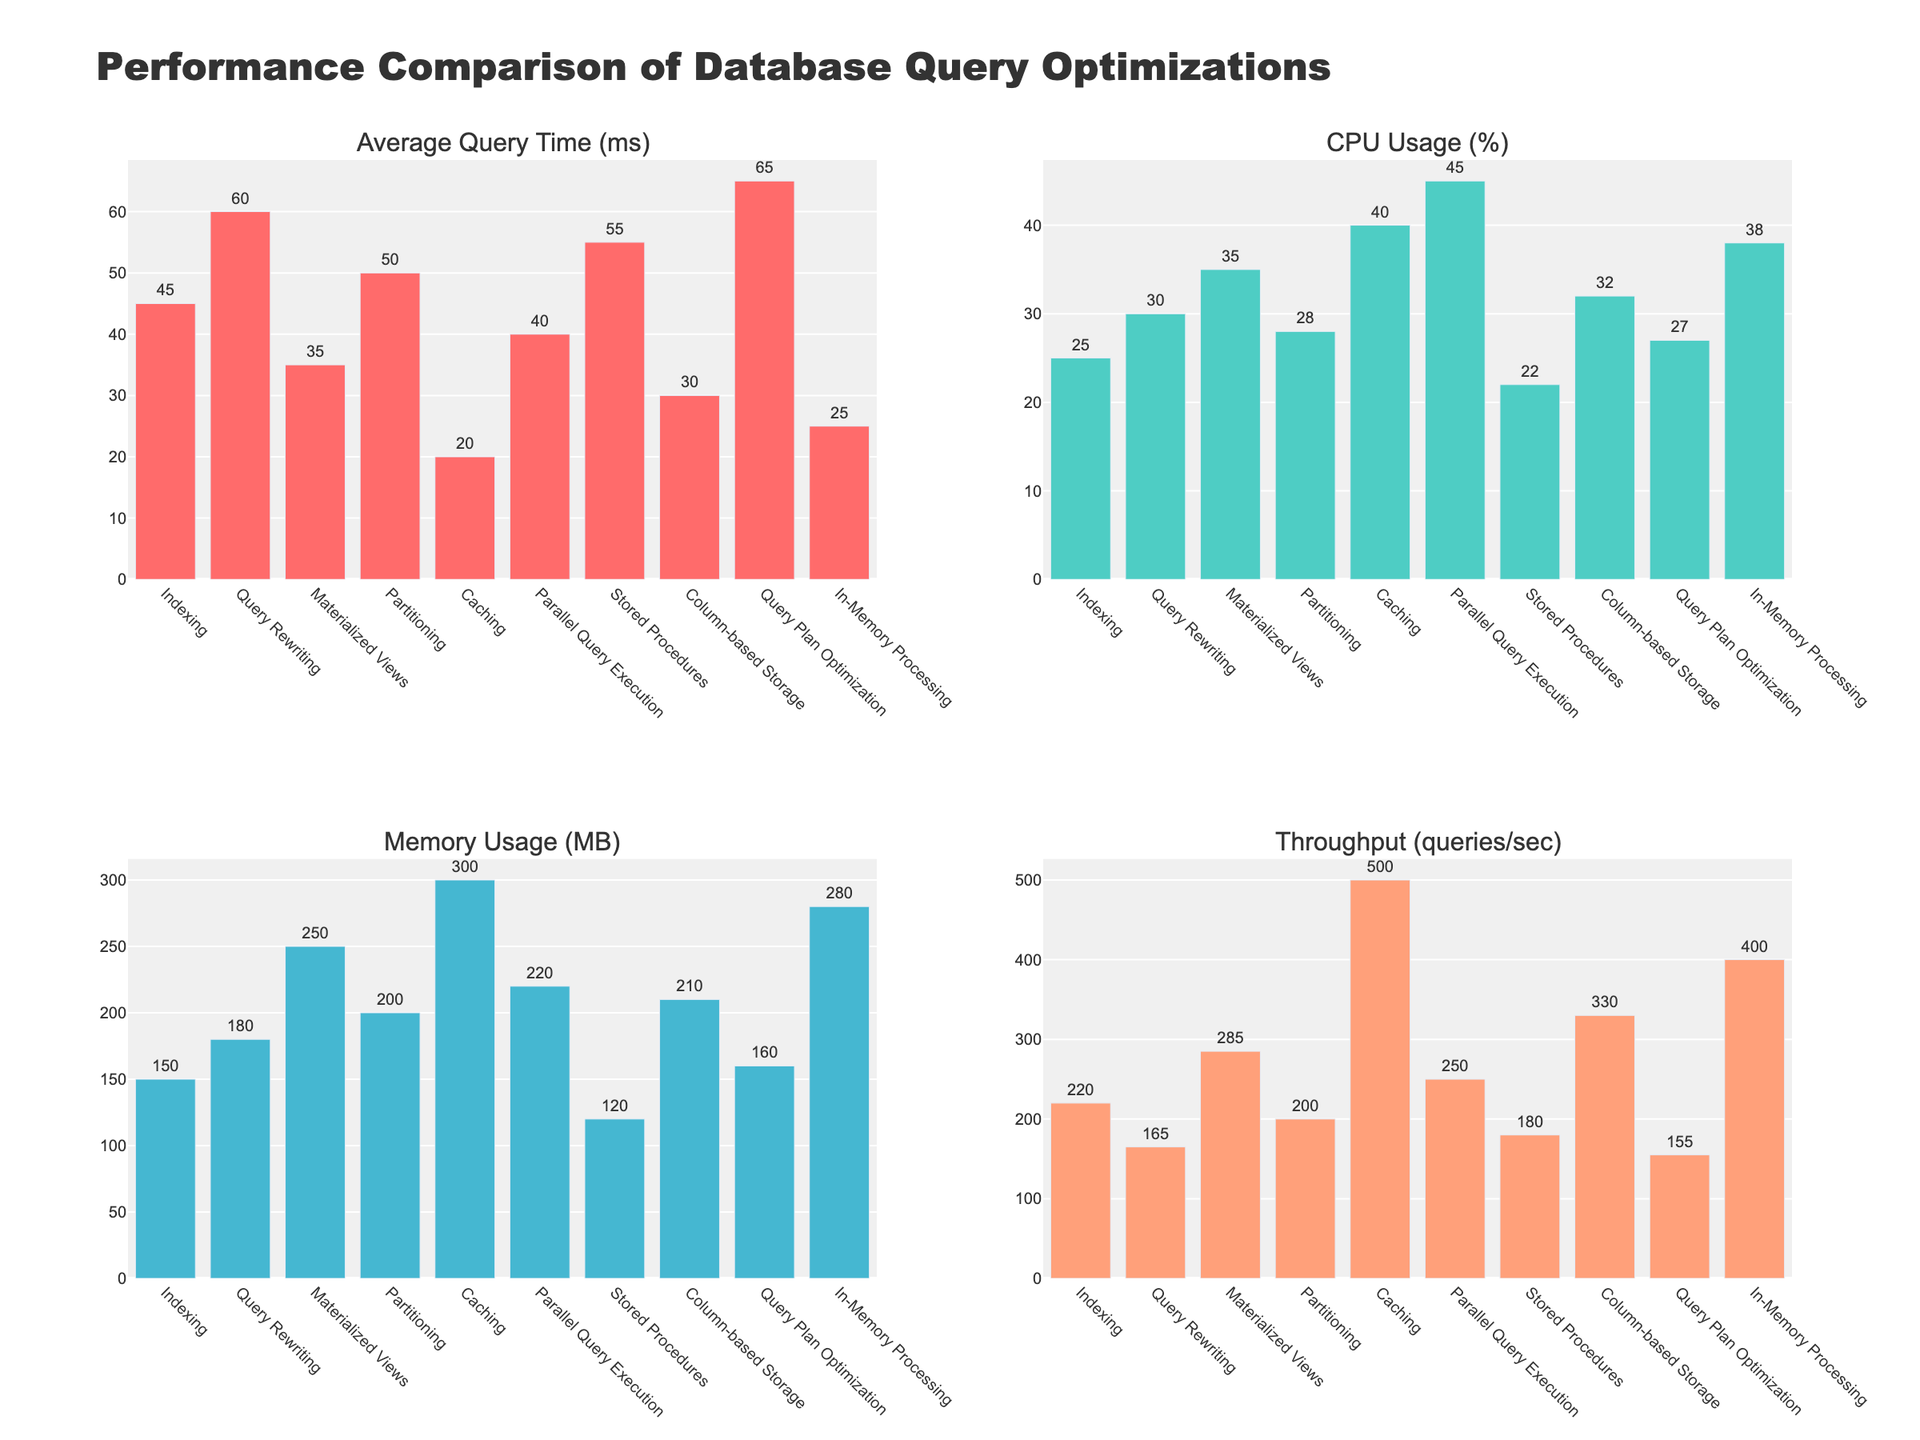Which query optimization technique has the lowest average query time? By visually inspecting the bar corresponding to 'Average Query Time (ms)', the bar for 'Caching' is the shortest, indicating it has the lowest average query time.
Answer: Caching Which technique uses the most CPU? By looking at the height of the bars in the 'CPU Usage (%)' subplot, 'Parallel Query Execution' has the tallest bar, which means it uses the most CPU.
Answer: Parallel Query Execution What's the difference in memory usage between materialized views and caching? The memory usage for 'Materialized Views' is 250 MB, and for 'Caching' it's 300 MB. Subtracting these gives 300 - 250 = 50 MB.
Answer: 50 MB Which technique has the highest throughput? Inspecting the 'Throughput (queries/sec)' subplot, the technique with the tallest bar is 'Caching', indicating it has the highest throughput.
Answer: Caching Compare the average query times of indexing and in-memory processing. Which is faster and by how much? The average query time for 'Indexing' is 45 ms, and for 'In-Memory Processing', it’s 25 ms. 'In-Memory Processing' is faster by 45 - 25 = 20 ms.
Answer: In-Memory Processing, 20 ms Which two techniques have the most similar memory usage? Looking at the heights of the memory usage bars, 'Column-based Storage' (210 MB) and 'Partitioning' (200 MB) appear to have very similar values, with a difference of only 10 MB.
Answer: Column-based Storage and Partitioning Compare the throughput and CPU usage for column-based storage. What can you infer? 'Column-based Storage' has high throughput at 330 queries/sec but uses only 32% CPU. This suggests it's efficient in handling large queries with relatively low CPU usage.
Answer: High throughput, low CPU usage Which technique has the second-lowest average query time? The second shortest bar in the 'Average Query Time (ms)' subplot corresponds to 'In-Memory Processing' at 25 ms, slightly higher than 'Caching'.
Answer: In-Memory Processing Does query plan optimization have a higher or lower CPU usage compared to in-memory processing? The 'CPU Usage (%)' for 'Query Plan Optimization' is 27%, while for 'In-Memory Processing' it is 38%. Therefore, 'Query Plan Optimization' has lower CPU usage.
Answer: Lower 